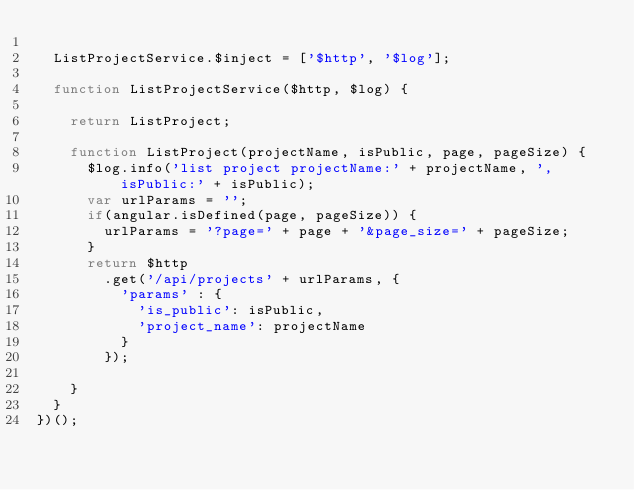Convert code to text. <code><loc_0><loc_0><loc_500><loc_500><_JavaScript_>  
  ListProjectService.$inject = ['$http', '$log'];
  
  function ListProjectService($http, $log) {
    
    return ListProject;
    
    function ListProject(projectName, isPublic, page, pageSize) {
      $log.info('list project projectName:' + projectName, ', isPublic:' + isPublic);
      var urlParams = '';
      if(angular.isDefined(page, pageSize)) {
        urlParams = '?page=' + page + '&page_size=' + pageSize;
      }
      return $http
        .get('/api/projects' + urlParams, {
          'params' : {
            'is_public': isPublic,
            'project_name': projectName
          }
        });
      
    }
  }
})();</code> 